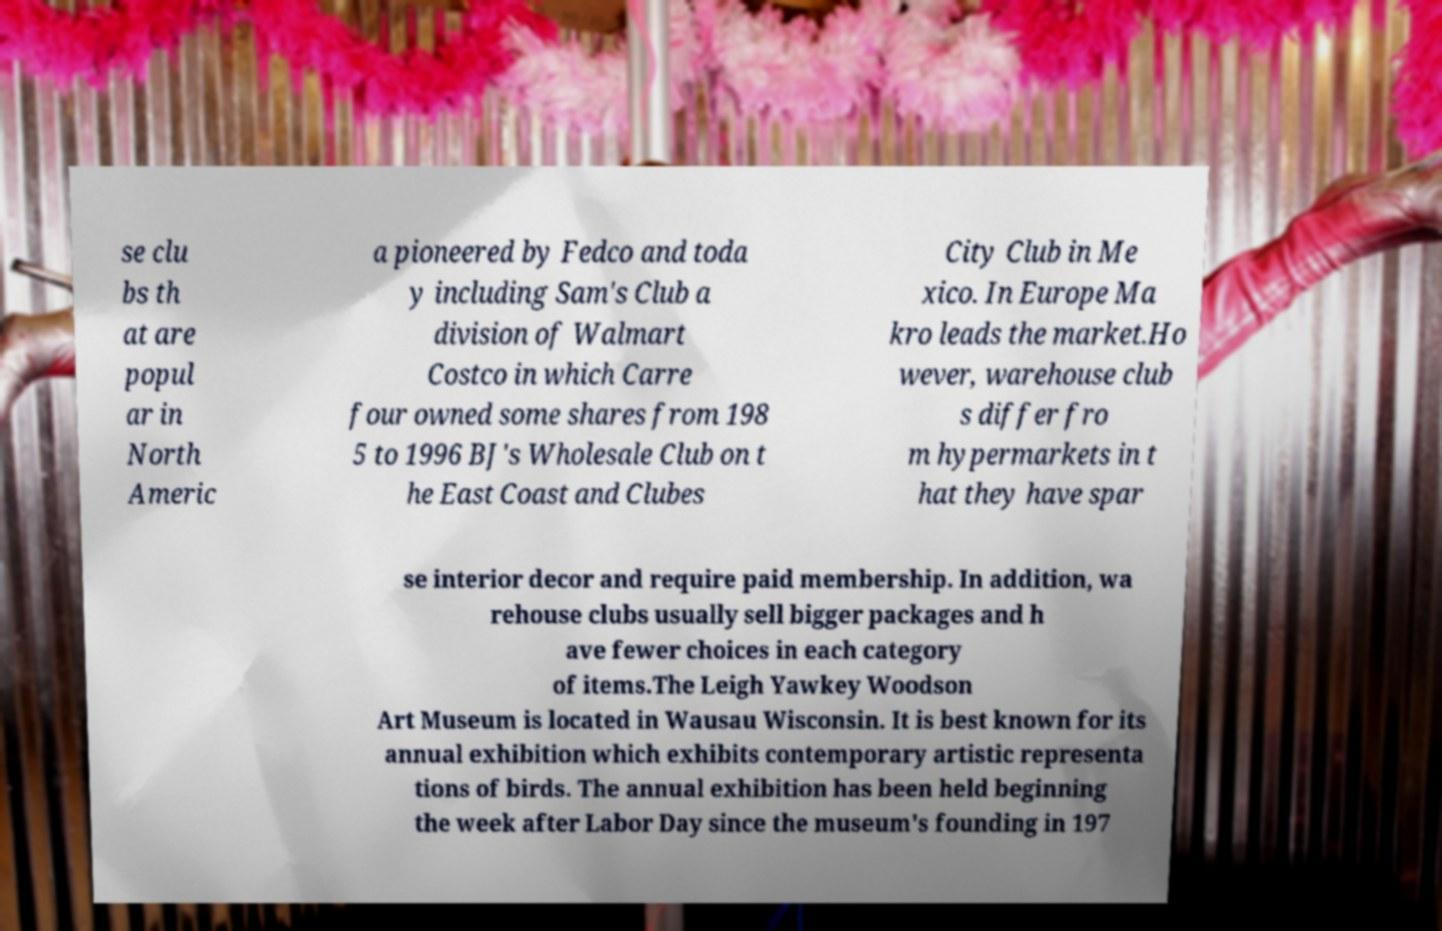What messages or text are displayed in this image? I need them in a readable, typed format. se clu bs th at are popul ar in North Americ a pioneered by Fedco and toda y including Sam's Club a division of Walmart Costco in which Carre four owned some shares from 198 5 to 1996 BJ's Wholesale Club on t he East Coast and Clubes City Club in Me xico. In Europe Ma kro leads the market.Ho wever, warehouse club s differ fro m hypermarkets in t hat they have spar se interior decor and require paid membership. In addition, wa rehouse clubs usually sell bigger packages and h ave fewer choices in each category of items.The Leigh Yawkey Woodson Art Museum is located in Wausau Wisconsin. It is best known for its annual exhibition which exhibits contemporary artistic representa tions of birds. The annual exhibition has been held beginning the week after Labor Day since the museum's founding in 197 